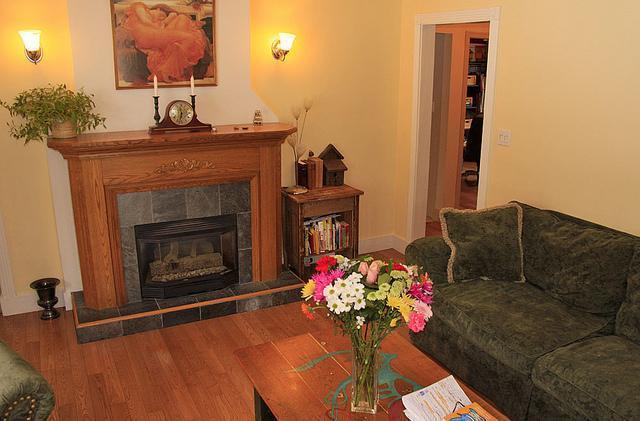How many couches are there?
Give a very brief answer. 2. How many carrots are on the plate?
Give a very brief answer. 0. 